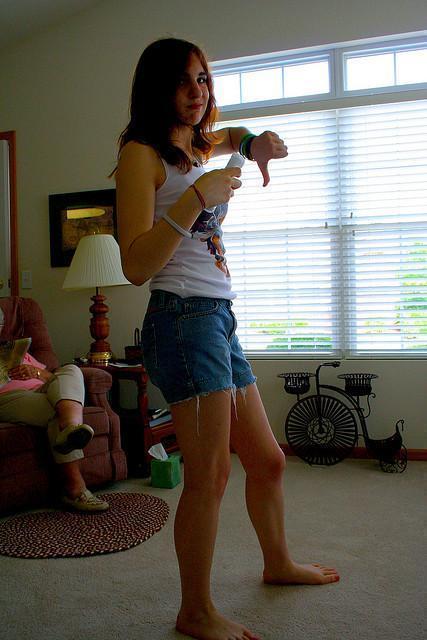What is the window covering called?
Choose the correct response, then elucidate: 'Answer: answer
Rationale: rationale.'
Options: Panels, curtains, blinds, shades. Answer: blinds.
Rationale: There are horizontal lines across the window that can be adjusted. 